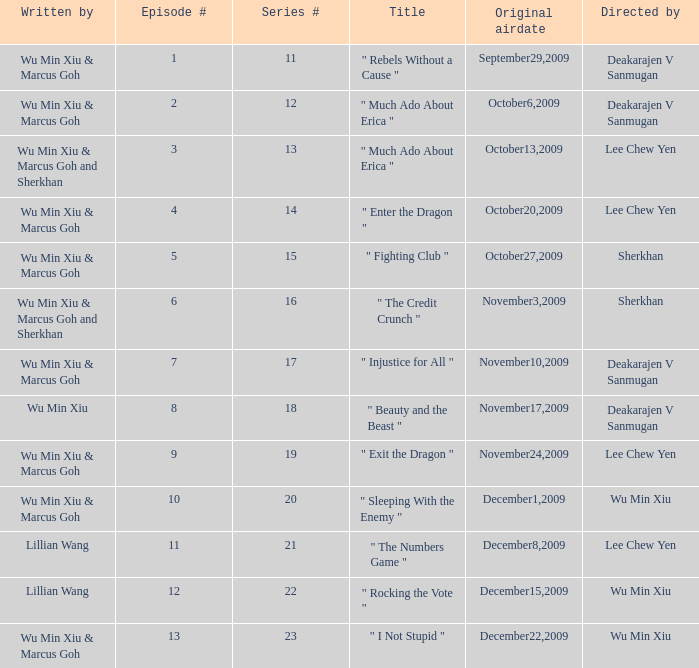What was the title for episode 2? " Much Ado About Erica ". 